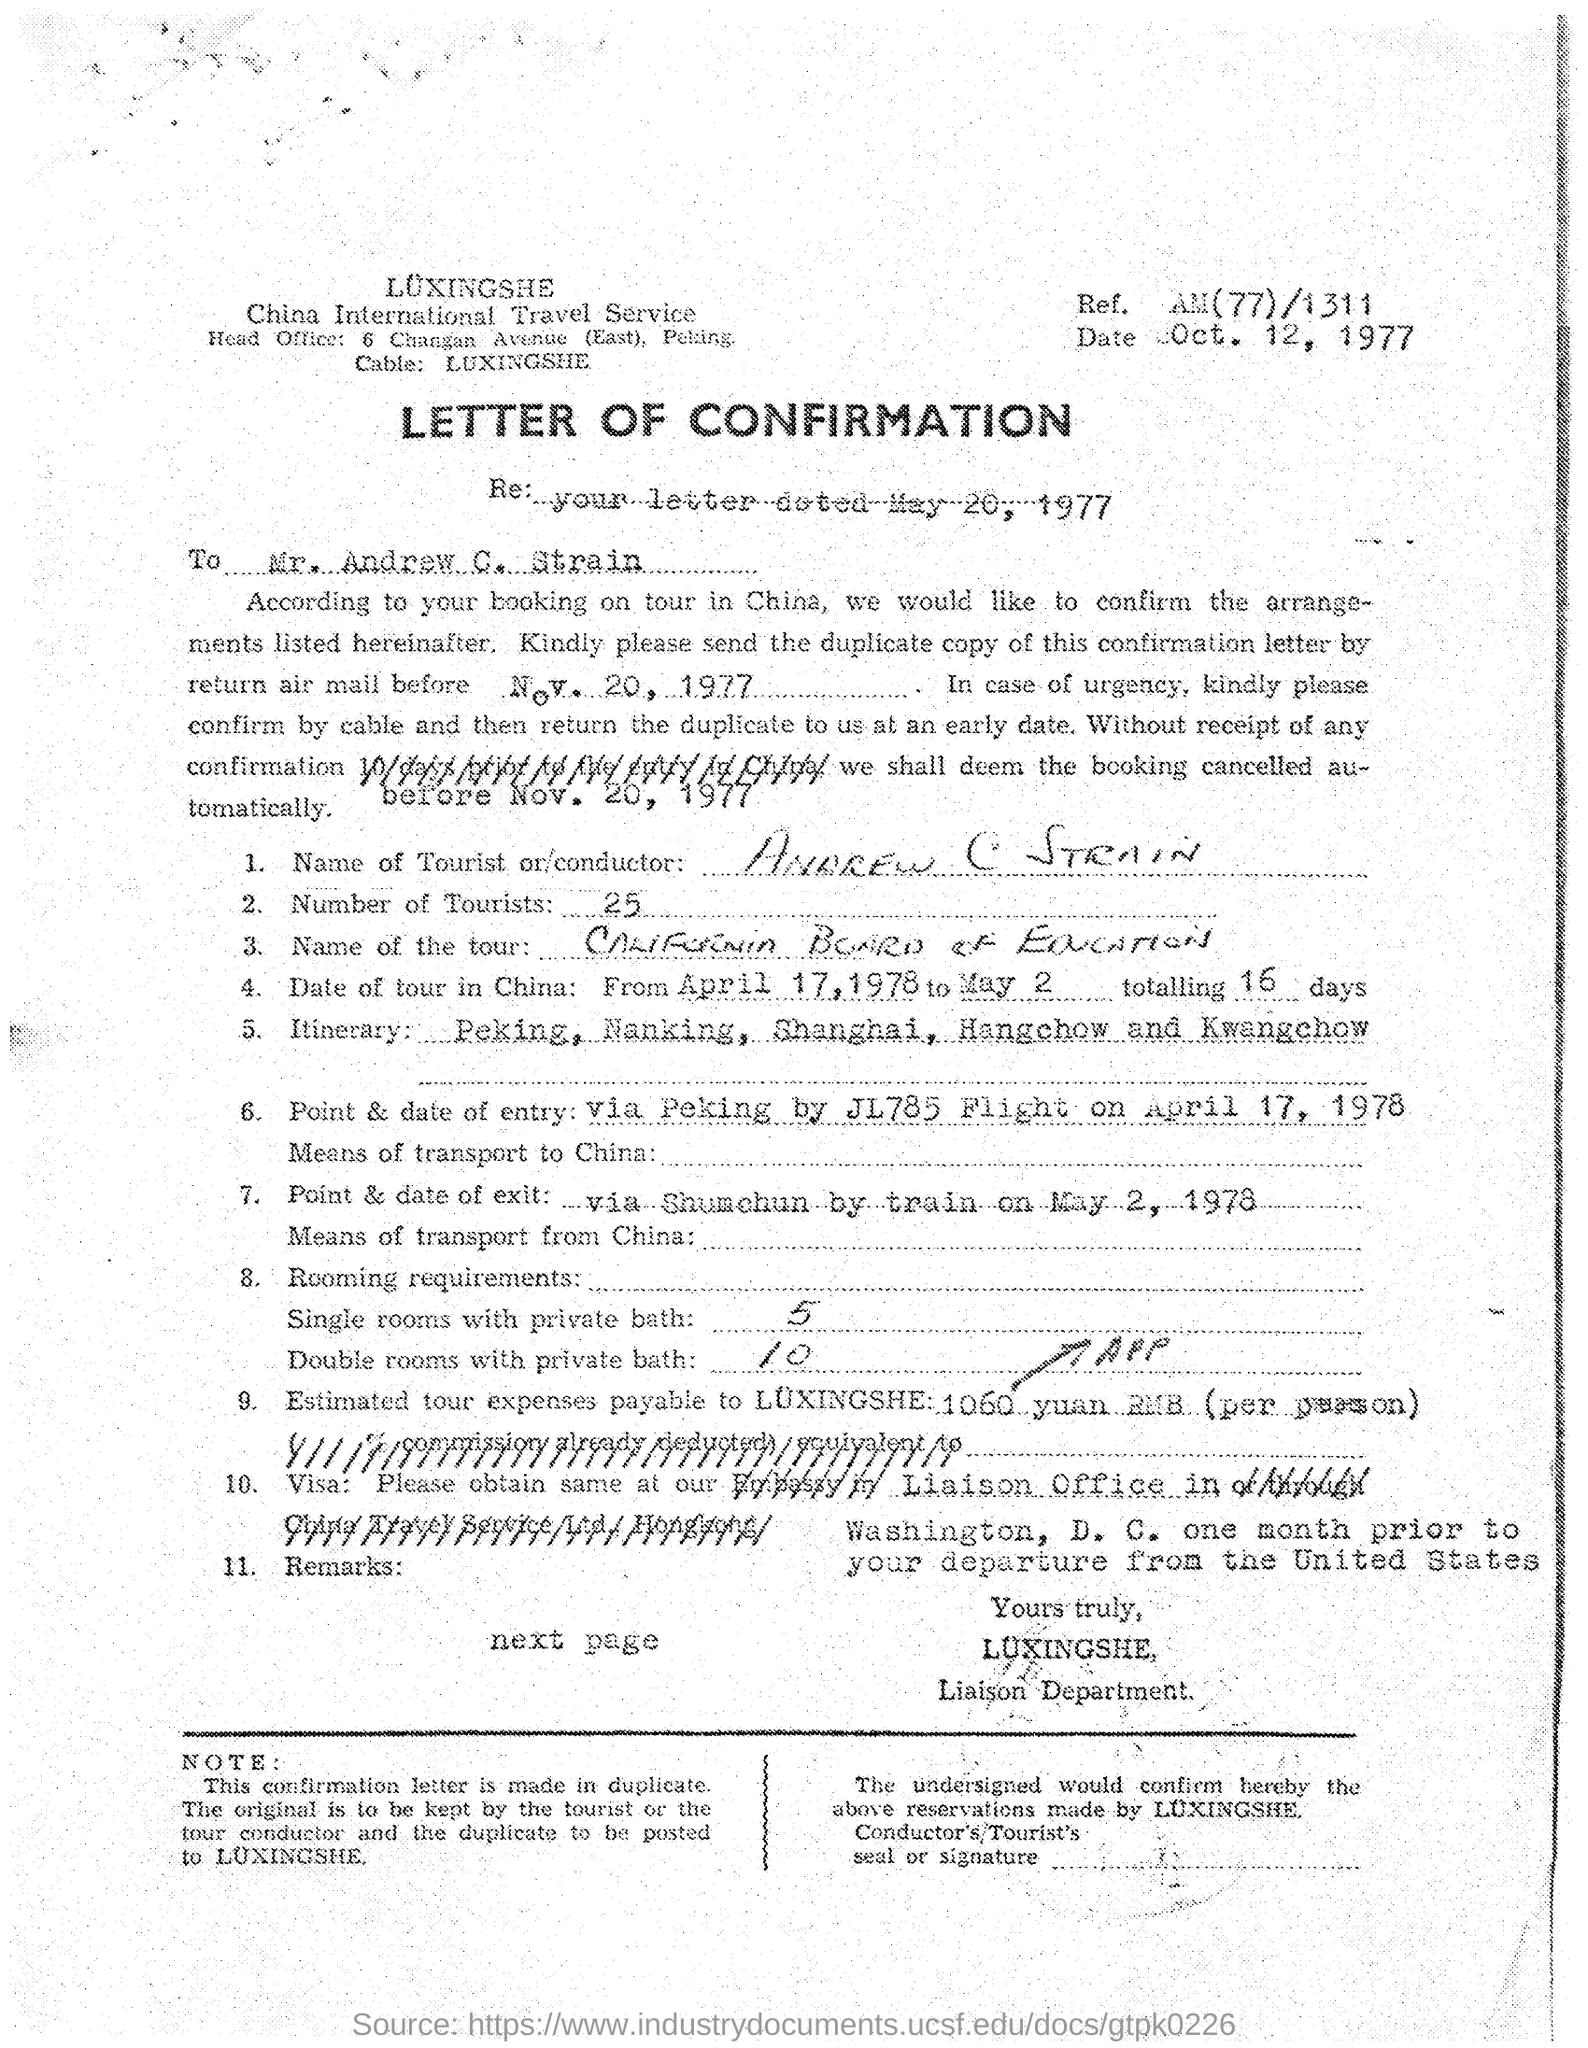What type of document is this?
Provide a short and direct response. Letter of confirmation. What is the date mentioned in the letterhead?
Make the answer very short. Oct. 12, 1977. What is the Ref No given in the letterhead?
Offer a very short reply. AM(77)/1311. What is the name of the tourist mentioned in the letter?
Ensure brevity in your answer.  ANDREW C STRAIN. How many number of tourists are there as per the document?
Keep it short and to the point. 25. How many double rooms with private bath are required as per the document?
Offer a very short reply. 10. How many single rooms with private bath are required as per the document?
Offer a very short reply. 5. 